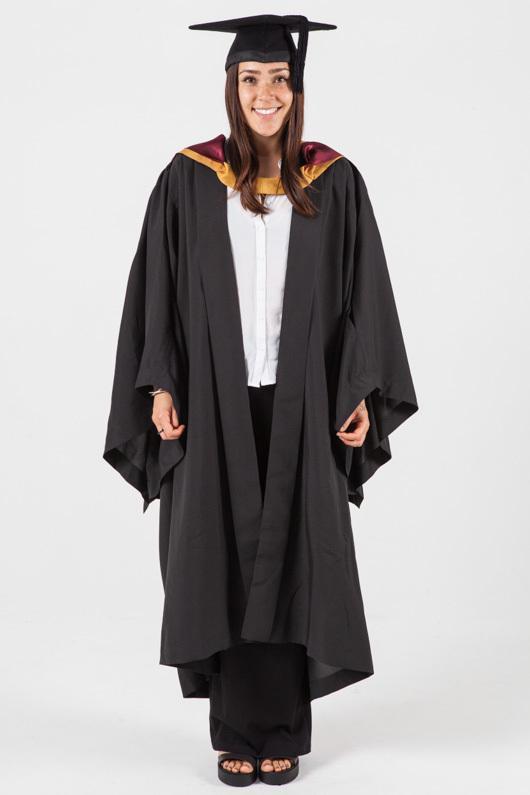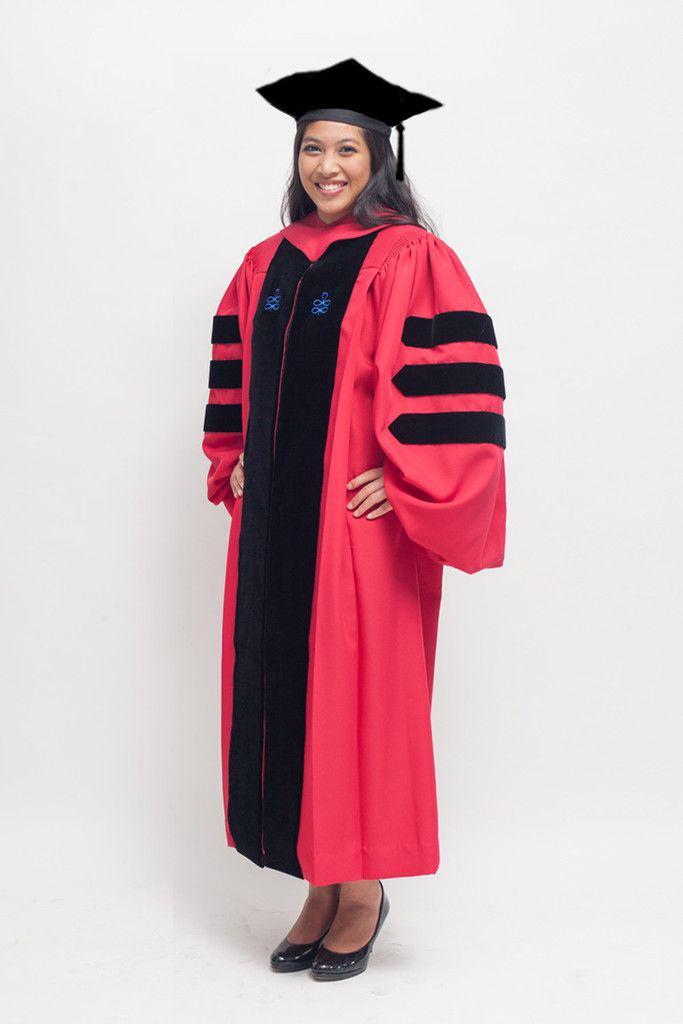The first image is the image on the left, the second image is the image on the right. For the images displayed, is the sentence "There is exactly one woman not holding a diploma in the image on the right" factually correct? Answer yes or no. Yes. The first image is the image on the left, the second image is the image on the right. For the images shown, is this caption "In one image a graduation gown worn by a woman is black and red." true? Answer yes or no. Yes. 